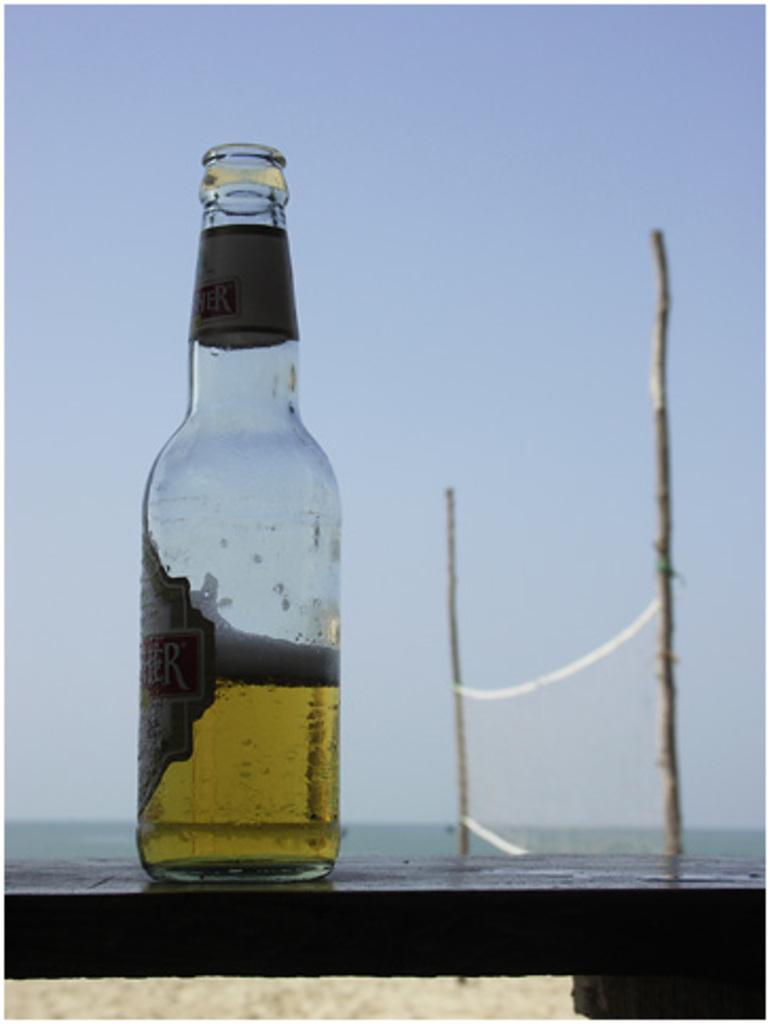What object is visible in the image? There is a bottle in the image. Where is the bottle located? The bottle is placed on a table. What can be seen in the background of the image? There is a net and the sky visible in the background of the image. What word is written on the bottle in the image? There is no word written on the bottle in the image. Can you see any animals from the zoo in the image? There are no animals from the zoo present in the image. 